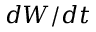Convert formula to latex. <formula><loc_0><loc_0><loc_500><loc_500>d W / d t</formula> 